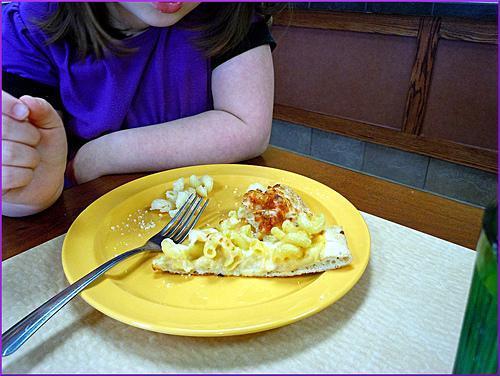How many people in the picture?
Give a very brief answer. 1. 